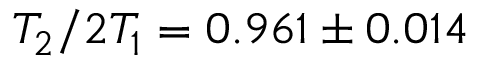Convert formula to latex. <formula><loc_0><loc_0><loc_500><loc_500>T _ { 2 } / 2 T _ { 1 } = 0 . 9 6 1 \pm 0 . 0 1 4</formula> 